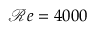Convert formula to latex. <formula><loc_0><loc_0><loc_500><loc_500>\mathcal { R } e = 4 0 0 0</formula> 